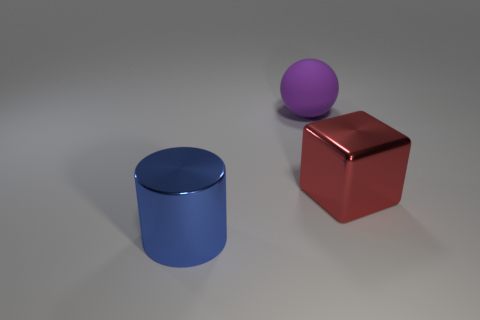Subtract all large purple rubber balls. Subtract all blue metallic objects. How many objects are left? 1 Add 3 big spheres. How many big spheres are left? 4 Add 3 rubber objects. How many rubber objects exist? 4 Add 1 big red metallic blocks. How many objects exist? 4 Subtract 0 gray balls. How many objects are left? 3 Subtract all spheres. How many objects are left? 2 Subtract 1 balls. How many balls are left? 0 Subtract all green cylinders. How many brown blocks are left? 0 